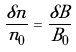Convert formula to latex. <formula><loc_0><loc_0><loc_500><loc_500>\frac { \delta n } { n _ { 0 } } = \frac { \delta B } { B _ { 0 } }</formula> 